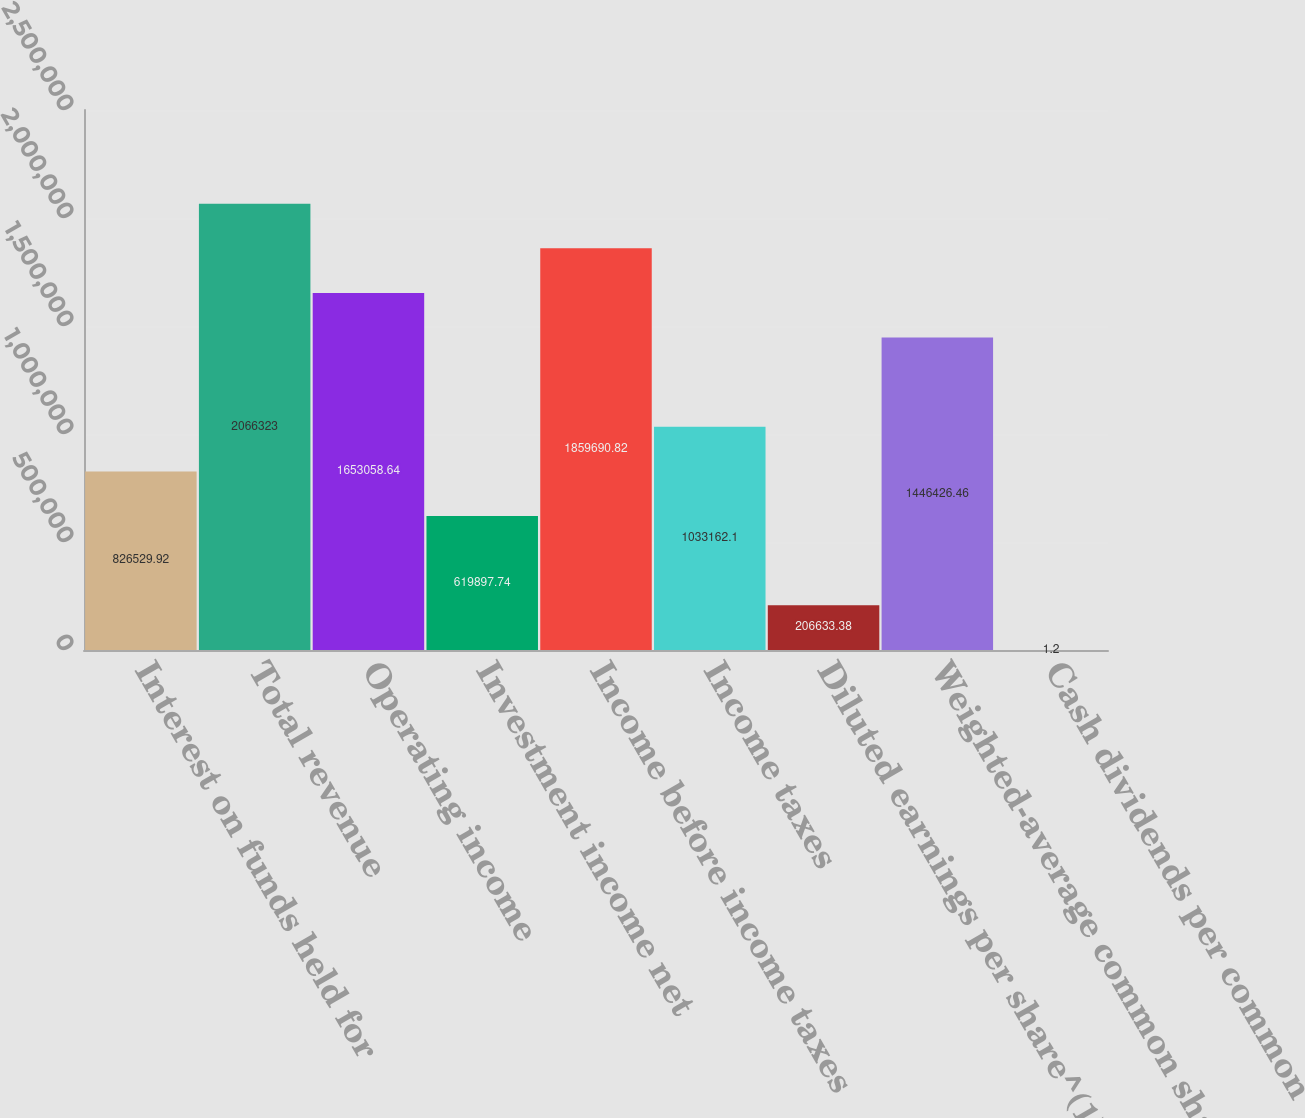<chart> <loc_0><loc_0><loc_500><loc_500><bar_chart><fcel>Interest on funds held for<fcel>Total revenue<fcel>Operating income<fcel>Investment income net<fcel>Income before income taxes<fcel>Income taxes<fcel>Diluted earnings per share^(1)<fcel>Weighted-average common shares<fcel>Cash dividends per common<nl><fcel>826530<fcel>2.06632e+06<fcel>1.65306e+06<fcel>619898<fcel>1.85969e+06<fcel>1.03316e+06<fcel>206633<fcel>1.44643e+06<fcel>1.2<nl></chart> 